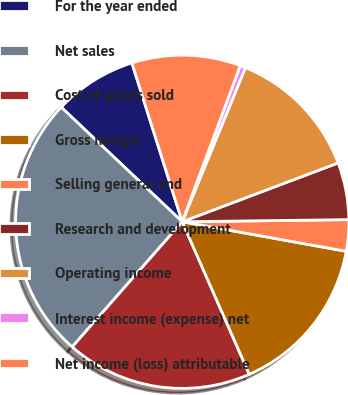Convert chart. <chart><loc_0><loc_0><loc_500><loc_500><pie_chart><fcel>For the year ended<fcel>Net sales<fcel>Cost of goods sold<fcel>Gross margin<fcel>Selling general and<fcel>Research and development<fcel>Operating income<fcel>Interest income (expense) net<fcel>Net income (loss) attributable<nl><fcel>8.05%<fcel>25.59%<fcel>18.07%<fcel>15.57%<fcel>3.04%<fcel>5.54%<fcel>13.06%<fcel>0.53%<fcel>10.55%<nl></chart> 